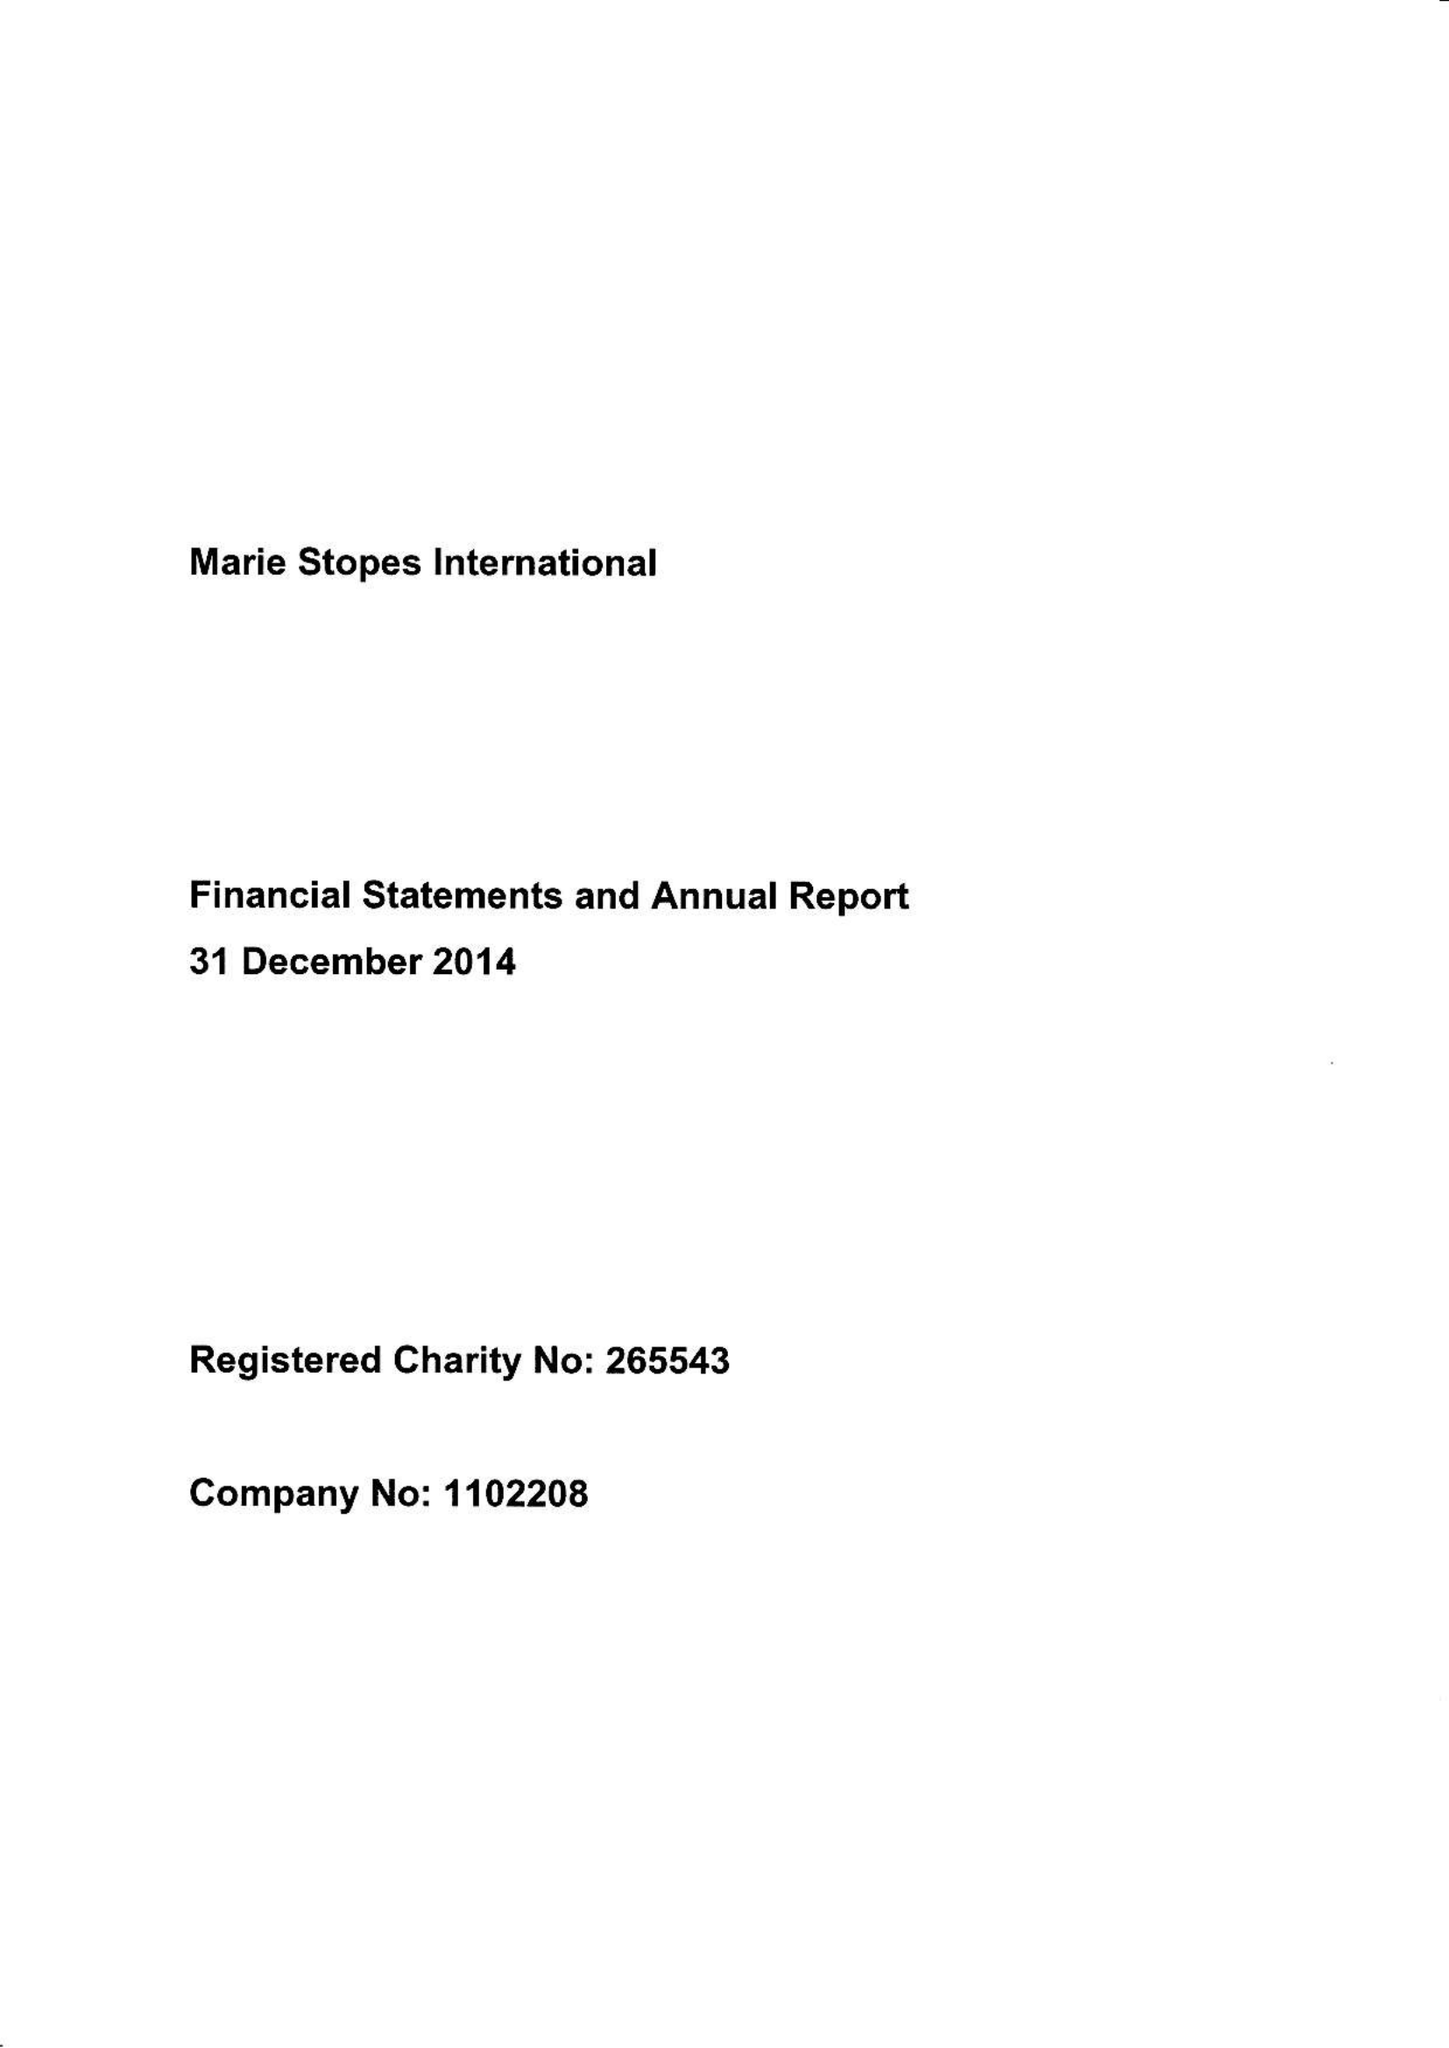What is the value for the address__post_town?
Answer the question using a single word or phrase. LONDON 